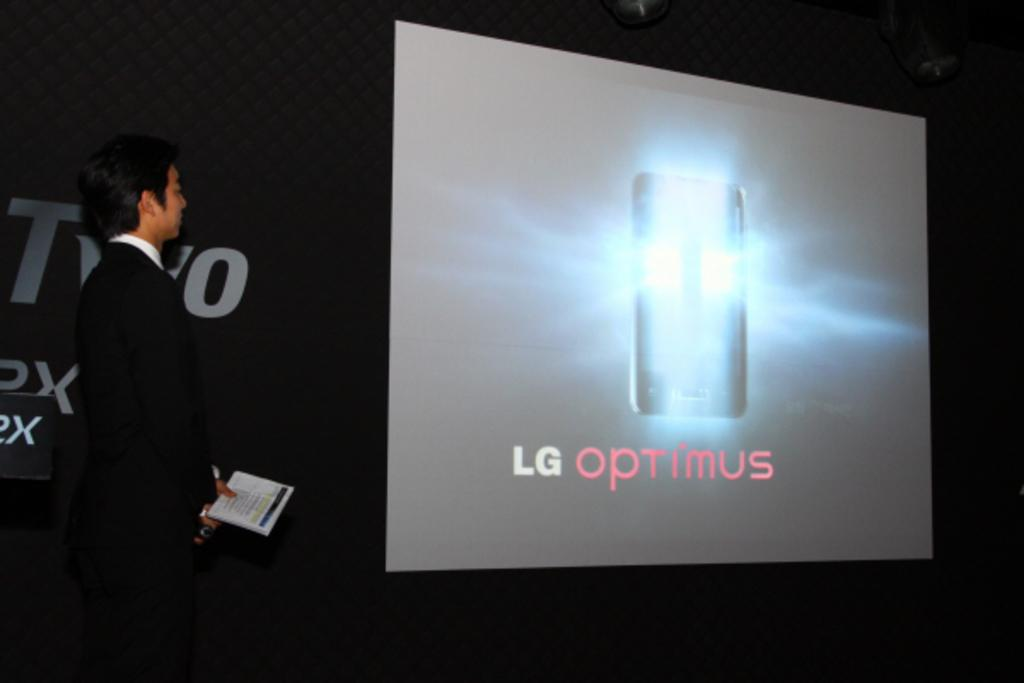What is the man on the left side of the image doing? The man is standing on the left side of the image and holding a microphone. What else is the man holding in his hand? The man is also holding a book in his hand. What can be seen in the background of the image? There is a hoarding and a screen in the background of the image. Can you see a mountain in the background of the image? No, there is no mountain visible in the background of the image. Is the man's thumb visible in the image? There is no specific mention of the man's thumb in the provided facts, so we cannot determine if it is visible in the image. 